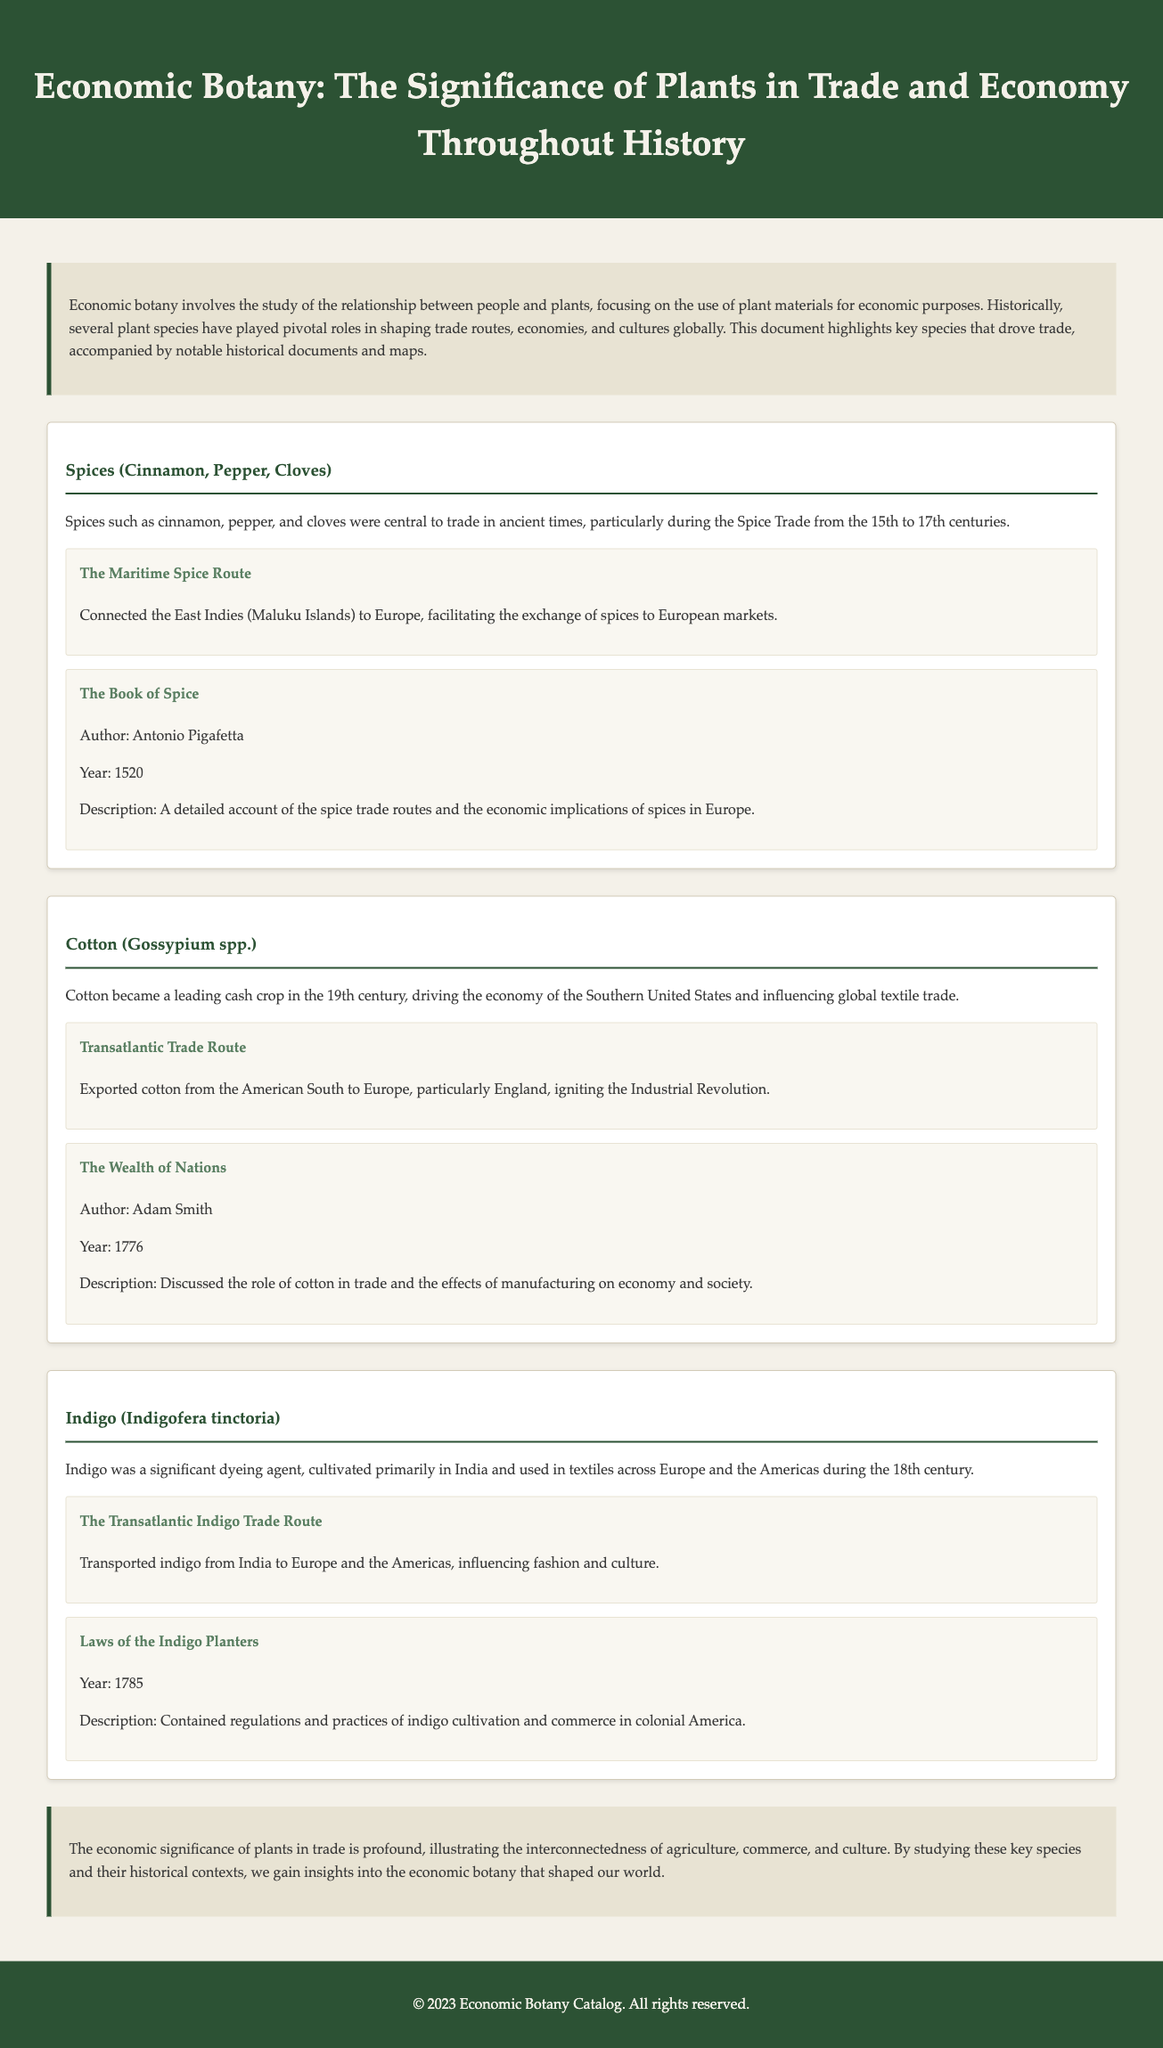What were the central spices traded during the Spice Trade? The document identifies cinnamon, pepper, and cloves as central spices in the trade during the 15th to 17th centuries.
Answer: cinnamon, pepper, cloves Who wrote "The Wealth of Nations"? The document states that "The Wealth of Nations" was authored by Adam Smith.
Answer: Adam Smith In what year was "The Book of Spice" published? The document specifies that "The Book of Spice" was published in the year 1520.
Answer: 1520 What is the primary cash crop mentioned for the Southern United States? The document highlights cotton as the leading cash crop in the 19th century for the Southern United States.
Answer: Cotton Which species is associated with dyeing agents in textiles? The document notes indigo as a significant dyeing agent used in textiles.
Answer: Indigo What economic effect did cotton have in relation to the Industrial Revolution? The document discusses how the export of cotton ignited the Industrial Revolution.
Answer: Ignited the Industrial Revolution What type of trade route is associated with indigo? The document mentions the Transatlantic Indigo Trade Route as associated with indigo.
Answer: Transatlantic Indigo Trade Route When were the "Laws of the Indigo Planters" established? The document indicates that the "Laws of the Indigo Planters" were established in 1785.
Answer: 1785 What was one of the main purposes of studying economic botany as stated in the conclusion? The conclusion reflects that studying key species and their historical contexts provides insights into economic botany.
Answer: Insights into economic botany 